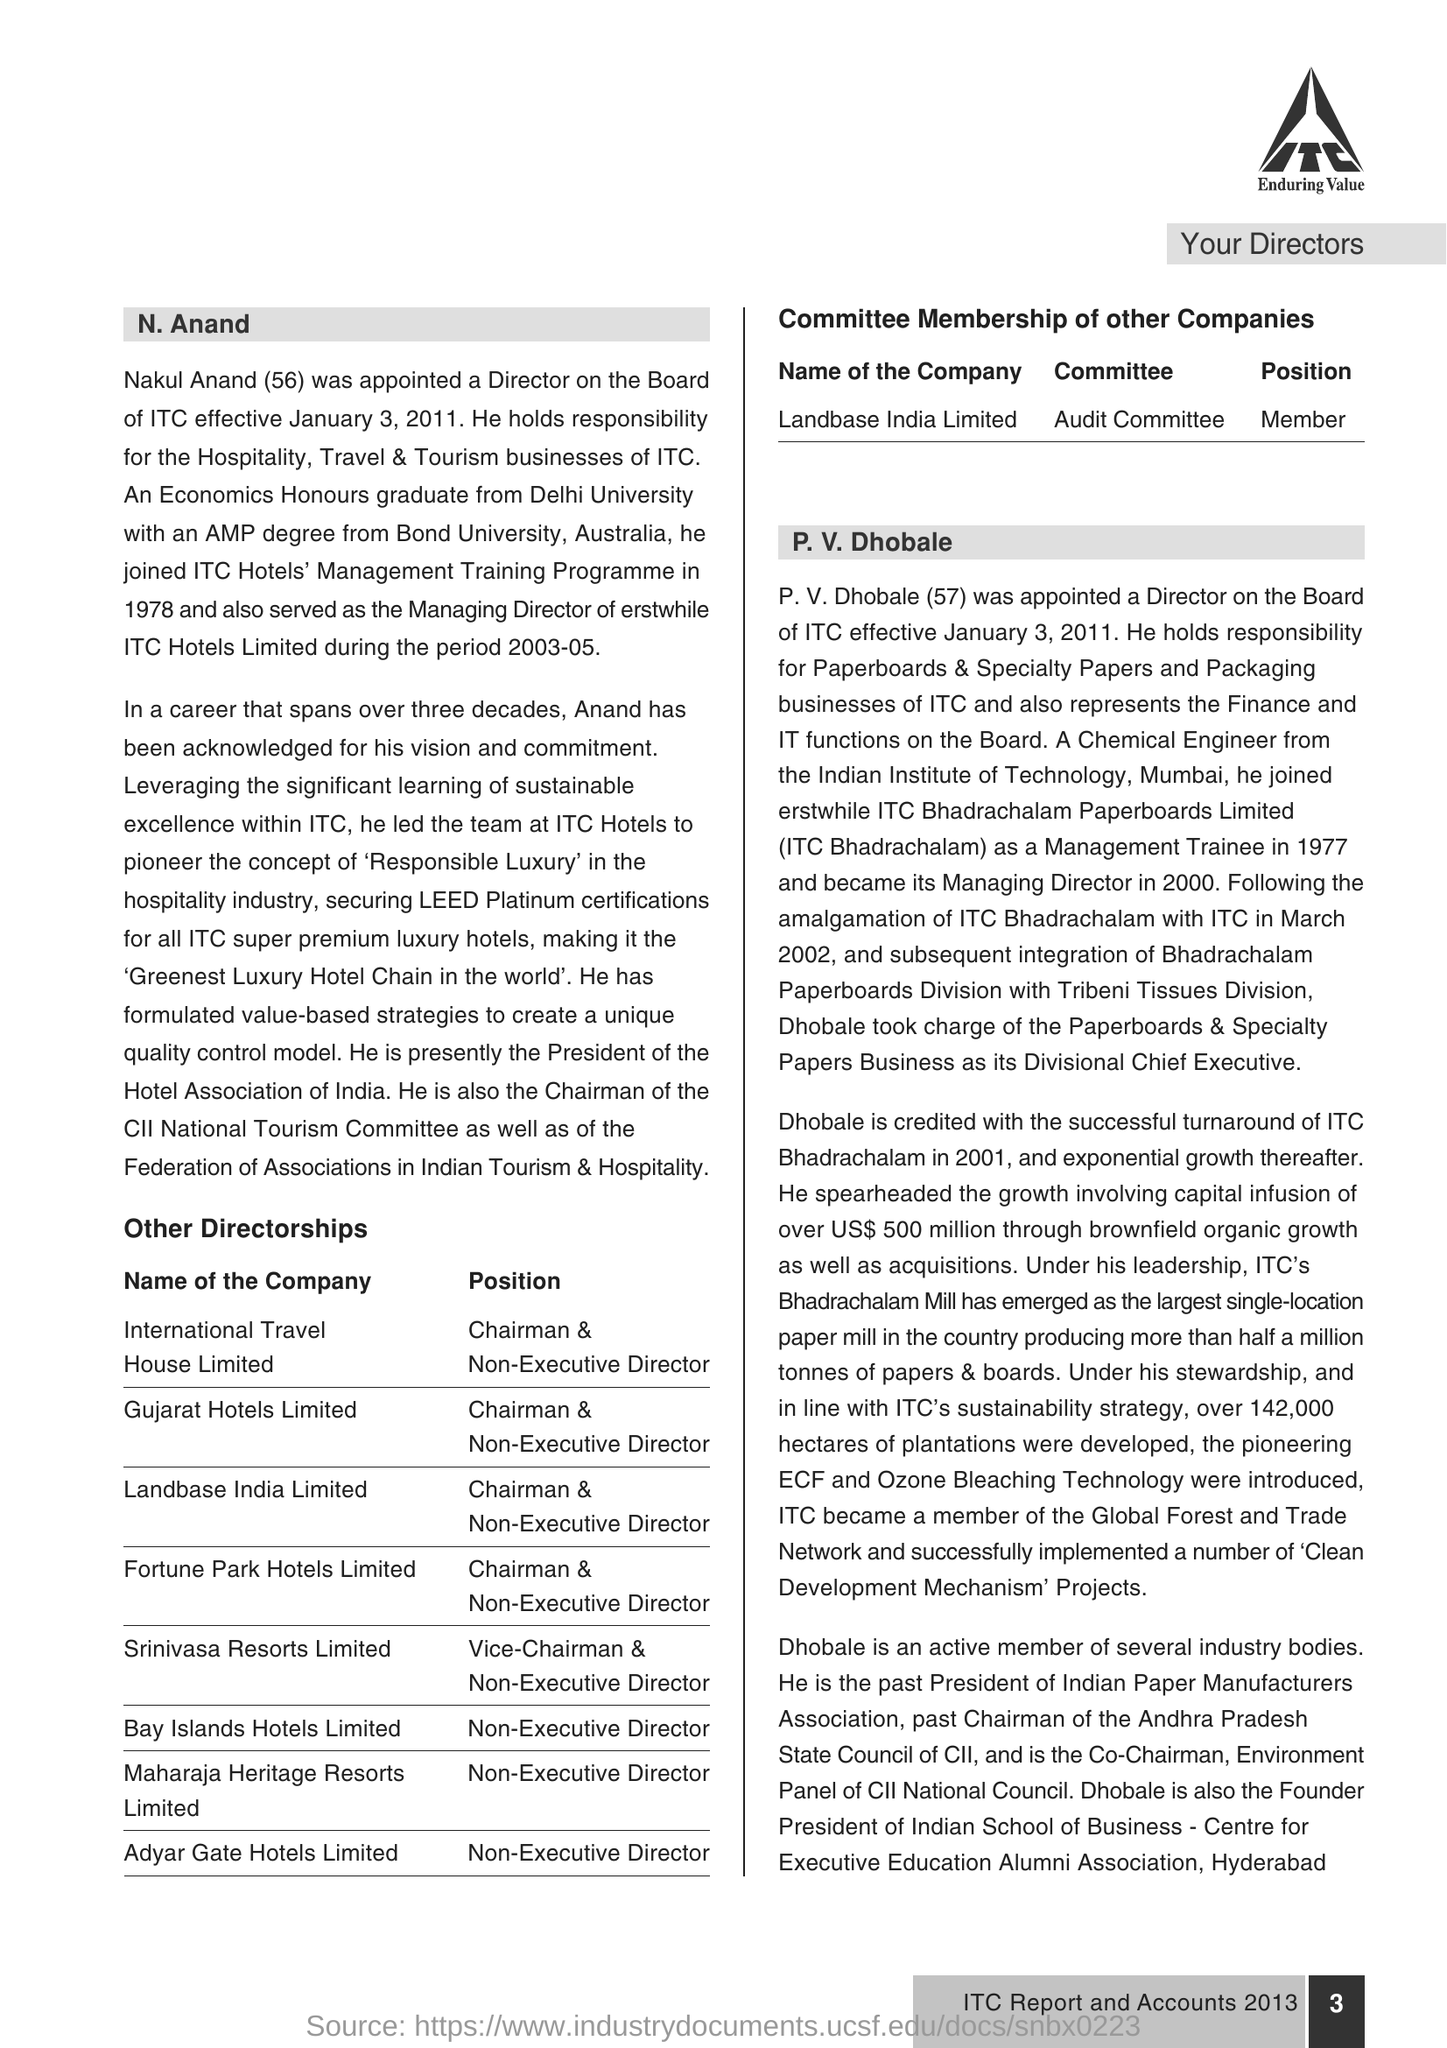Draw attention to some important aspects in this diagram. The age of P.V Dhobale is 57. N Anand is 56 years old. As of January 3, 2011, N Anand was appointed. Nakul Anand is known by the full name of N Anand. 